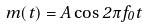<formula> <loc_0><loc_0><loc_500><loc_500>m ( t ) = A \cos 2 \pi f _ { 0 } t</formula> 